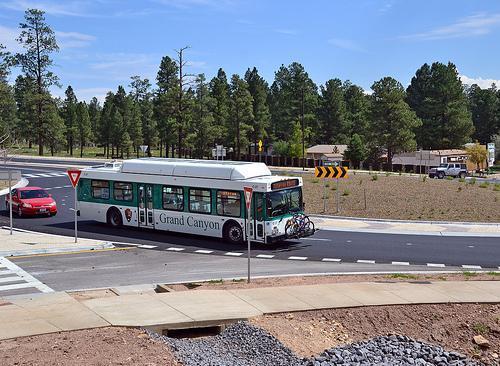How many buses are in the picture?
Give a very brief answer. 1. 